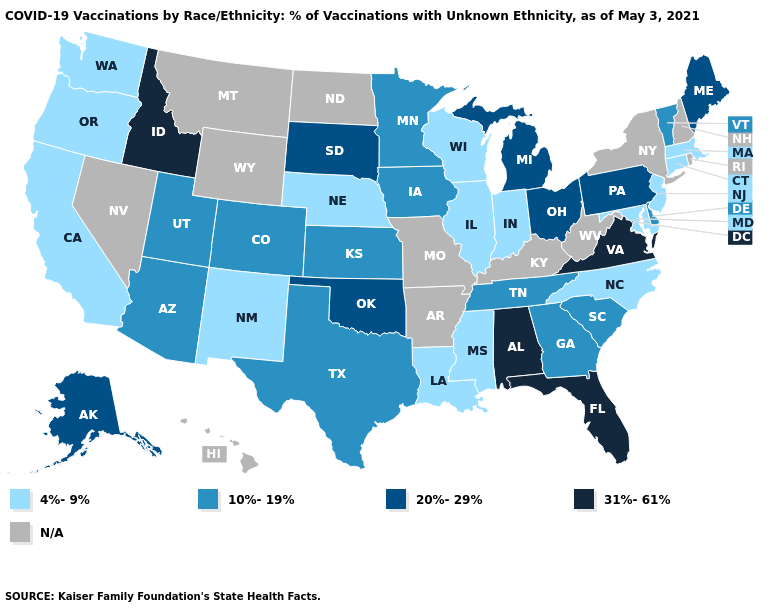Which states have the lowest value in the USA?
Keep it brief. California, Connecticut, Illinois, Indiana, Louisiana, Maryland, Massachusetts, Mississippi, Nebraska, New Jersey, New Mexico, North Carolina, Oregon, Washington, Wisconsin. Does the map have missing data?
Keep it brief. Yes. Which states have the lowest value in the USA?
Quick response, please. California, Connecticut, Illinois, Indiana, Louisiana, Maryland, Massachusetts, Mississippi, Nebraska, New Jersey, New Mexico, North Carolina, Oregon, Washington, Wisconsin. What is the value of Kentucky?
Quick response, please. N/A. Among the states that border Delaware , does Pennsylvania have the lowest value?
Write a very short answer. No. Which states have the lowest value in the USA?
Keep it brief. California, Connecticut, Illinois, Indiana, Louisiana, Maryland, Massachusetts, Mississippi, Nebraska, New Jersey, New Mexico, North Carolina, Oregon, Washington, Wisconsin. Name the states that have a value in the range N/A?
Concise answer only. Arkansas, Hawaii, Kentucky, Missouri, Montana, Nevada, New Hampshire, New York, North Dakota, Rhode Island, West Virginia, Wyoming. Which states have the highest value in the USA?
Give a very brief answer. Alabama, Florida, Idaho, Virginia. What is the value of Ohio?
Be succinct. 20%-29%. What is the value of Texas?
Write a very short answer. 10%-19%. What is the value of New Mexico?
Give a very brief answer. 4%-9%. What is the value of Kansas?
Give a very brief answer. 10%-19%. Which states have the lowest value in the USA?
Be succinct. California, Connecticut, Illinois, Indiana, Louisiana, Maryland, Massachusetts, Mississippi, Nebraska, New Jersey, New Mexico, North Carolina, Oregon, Washington, Wisconsin. What is the lowest value in the USA?
Short answer required. 4%-9%. Does Nebraska have the lowest value in the USA?
Write a very short answer. Yes. 